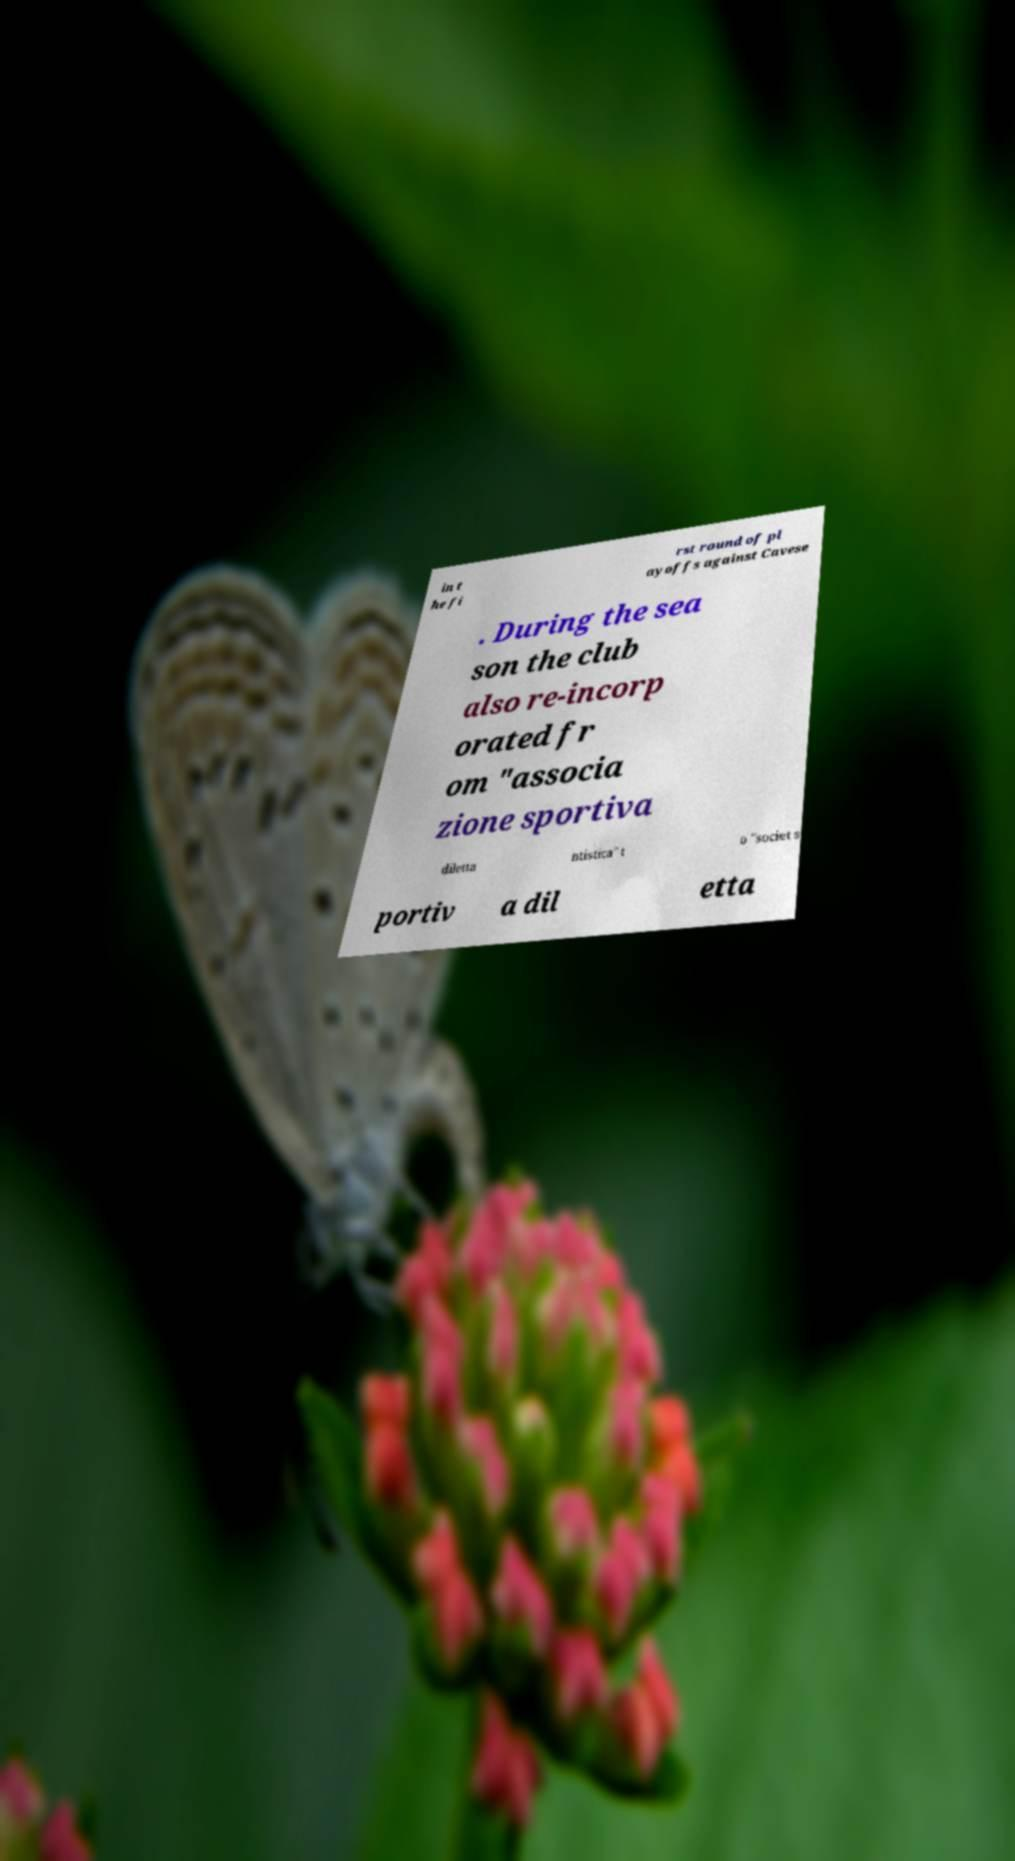Could you assist in decoding the text presented in this image and type it out clearly? in t he fi rst round of pl ayoffs against Cavese . During the sea son the club also re-incorp orated fr om "associa zione sportiva diletta ntistica" t o "societ s portiv a dil etta 